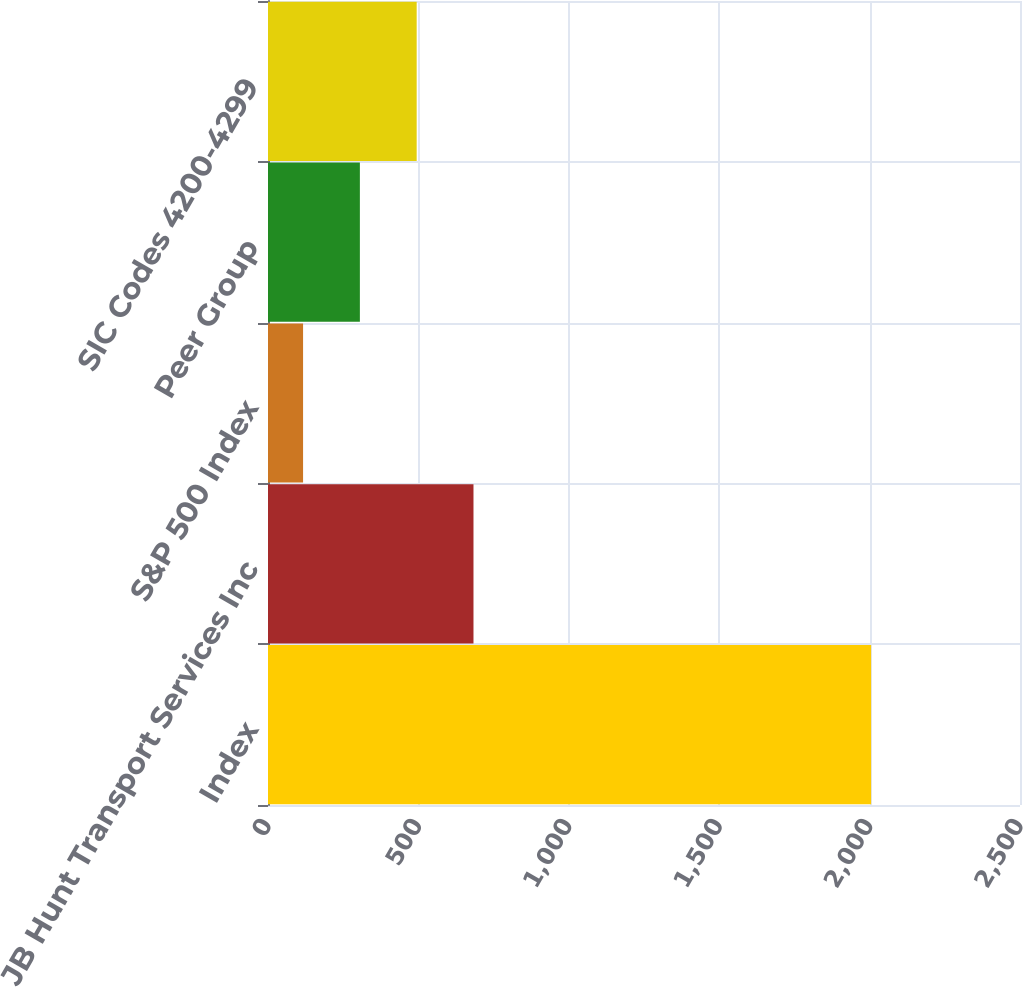Convert chart to OTSL. <chart><loc_0><loc_0><loc_500><loc_500><bar_chart><fcel>Index<fcel>JB Hunt Transport Services Inc<fcel>S&P 500 Index<fcel>Peer Group<fcel>SIC Codes 4200-4299<nl><fcel>2005<fcel>683.12<fcel>116.6<fcel>305.44<fcel>494.28<nl></chart> 